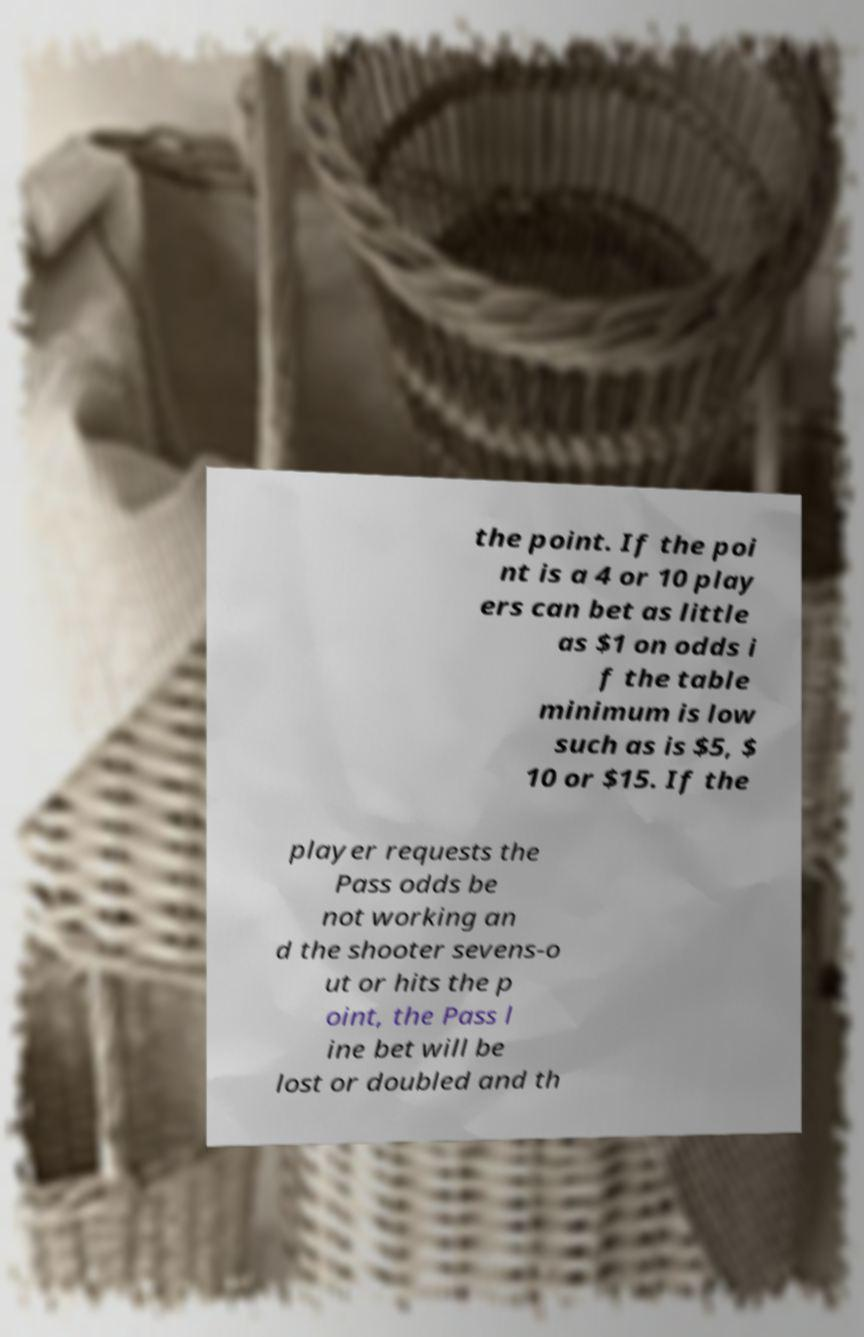What messages or text are displayed in this image? I need them in a readable, typed format. the point. If the poi nt is a 4 or 10 play ers can bet as little as $1 on odds i f the table minimum is low such as is $5, $ 10 or $15. If the player requests the Pass odds be not working an d the shooter sevens-o ut or hits the p oint, the Pass l ine bet will be lost or doubled and th 